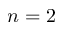<formula> <loc_0><loc_0><loc_500><loc_500>{ n = 2 }</formula> 